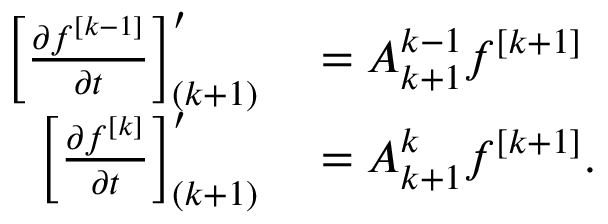Convert formula to latex. <formula><loc_0><loc_0><loc_500><loc_500>\begin{array} { r l } { \left [ { \frac { \partial f ^ { [ k - 1 ] } } { \partial t } } \right ] _ { ( k + 1 ) } ^ { \prime } } & = A _ { k + 1 } ^ { k - 1 } f ^ { [ k + 1 ] } } \\ { \left [ { \frac { \partial f ^ { [ k ] } } { \partial t } } \right ] _ { ( k + 1 ) } ^ { \prime } } & = A _ { k + 1 } ^ { k } f ^ { [ k + 1 ] } . } \end{array}</formula> 